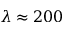Convert formula to latex. <formula><loc_0><loc_0><loc_500><loc_500>\lambda \approx 2 0 0</formula> 